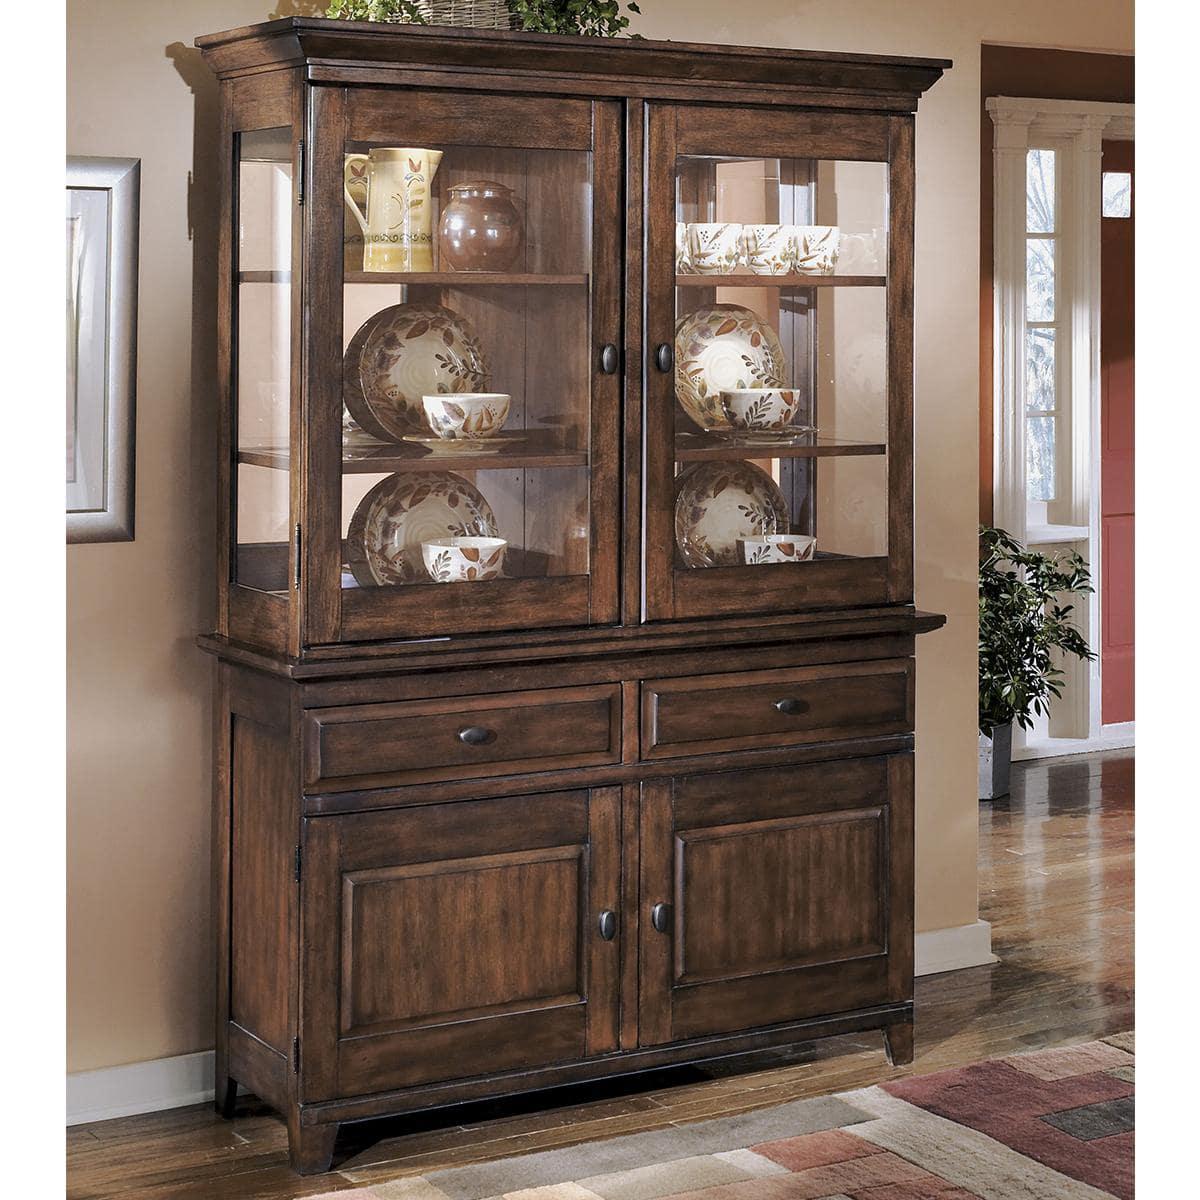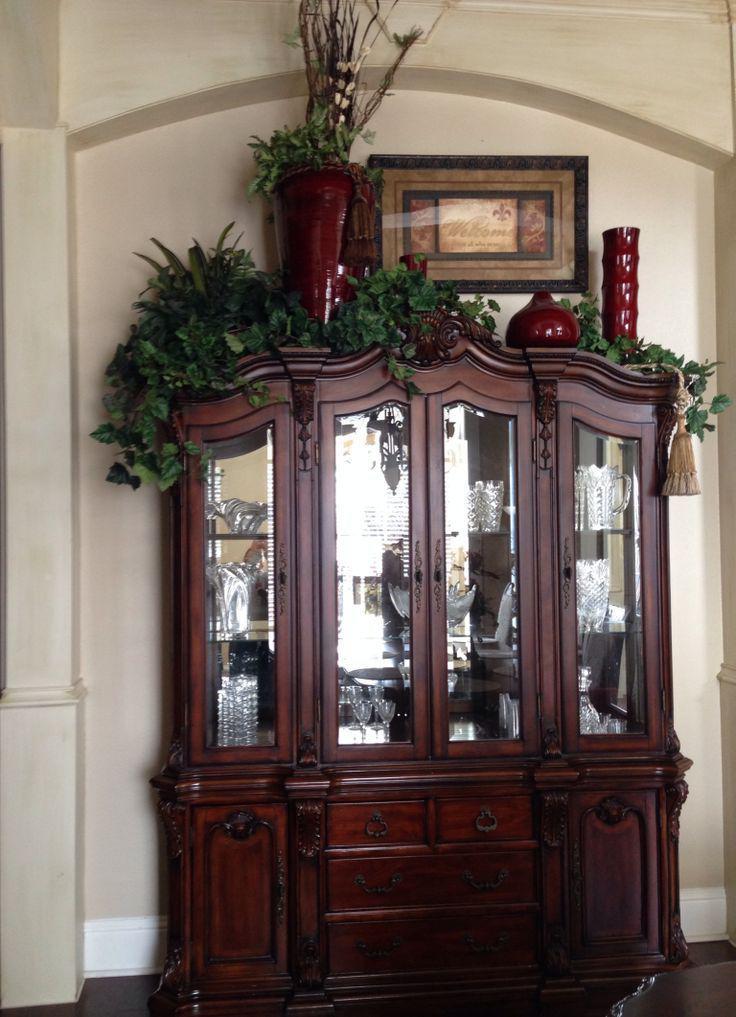The first image is the image on the left, the second image is the image on the right. Assess this claim about the two images: "There is a floor plant near a hutch in one of the images.". Correct or not? Answer yes or no. Yes. The first image is the image on the left, the second image is the image on the right. For the images shown, is this caption "There is one picture frame in the image on the right." true? Answer yes or no. Yes. The first image is the image on the left, the second image is the image on the right. Considering the images on both sides, is "One of the wooden cabinets is not flat across the top." valid? Answer yes or no. Yes. The first image is the image on the left, the second image is the image on the right. Considering the images on both sides, is "One of the cabinets is dark wood with four glass doors and a non-flat top." valid? Answer yes or no. Yes. 